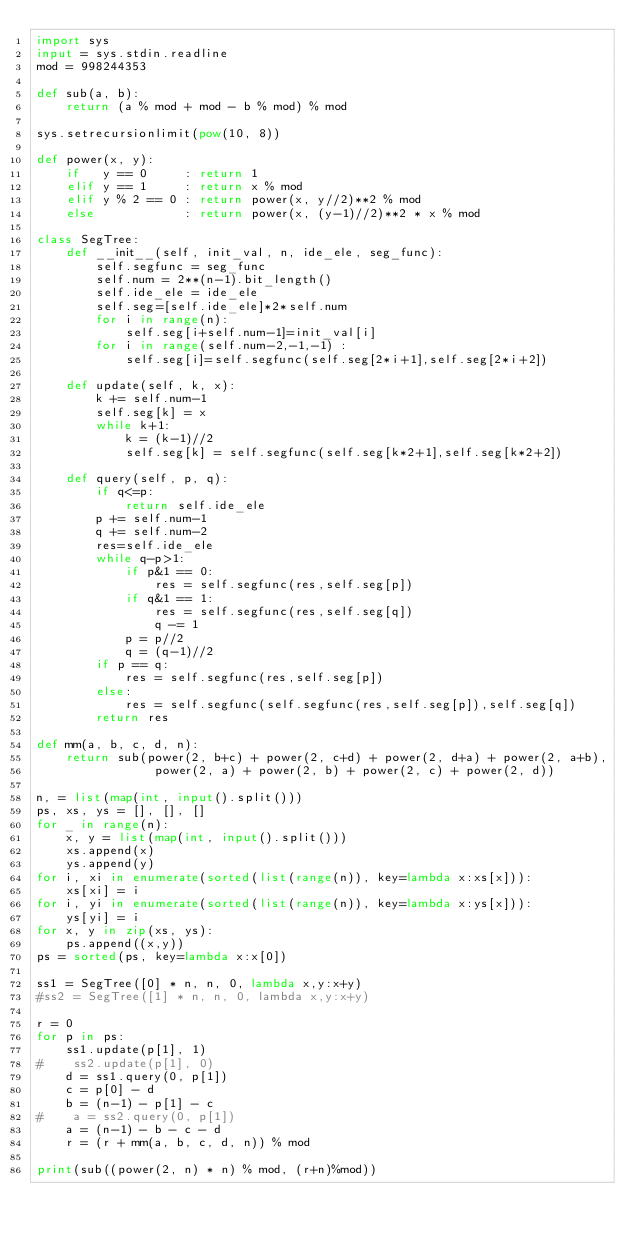Convert code to text. <code><loc_0><loc_0><loc_500><loc_500><_Python_>import sys
input = sys.stdin.readline
mod = 998244353

def sub(a, b):
    return (a % mod + mod - b % mod) % mod

sys.setrecursionlimit(pow(10, 8))

def power(x, y):
    if   y == 0     : return 1
    elif y == 1     : return x % mod
    elif y % 2 == 0 : return power(x, y//2)**2 % mod
    else            : return power(x, (y-1)//2)**2 * x % mod

class SegTree:
    def __init__(self, init_val, n, ide_ele, seg_func):
        self.segfunc = seg_func
        self.num = 2**(n-1).bit_length()
        self.ide_ele = ide_ele
        self.seg=[self.ide_ele]*2*self.num
        for i in range(n):
            self.seg[i+self.num-1]=init_val[i]    
        for i in range(self.num-2,-1,-1) :
            self.seg[i]=self.segfunc(self.seg[2*i+1],self.seg[2*i+2]) 
        
    def update(self, k, x):
        k += self.num-1
        self.seg[k] = x
        while k+1:
            k = (k-1)//2
            self.seg[k] = self.segfunc(self.seg[k*2+1],self.seg[k*2+2])
        
    def query(self, p, q):
        if q<=p:
            return self.ide_ele
        p += self.num-1
        q += self.num-2
        res=self.ide_ele
        while q-p>1:
            if p&1 == 0:
                res = self.segfunc(res,self.seg[p])
            if q&1 == 1:
                res = self.segfunc(res,self.seg[q])
                q -= 1
            p = p//2
            q = (q-1)//2
        if p == q:
            res = self.segfunc(res,self.seg[p])
        else:
            res = self.segfunc(self.segfunc(res,self.seg[p]),self.seg[q])
        return res

def mm(a, b, c, d, n):
    return sub(power(2, b+c) + power(2, c+d) + power(2, d+a) + power(2, a+b),
                power(2, a) + power(2, b) + power(2, c) + power(2, d))

n, = list(map(int, input().split()))
ps, xs, ys = [], [], []
for _ in range(n):
    x, y = list(map(int, input().split()))
    xs.append(x)
    ys.append(y)
for i, xi in enumerate(sorted(list(range(n)), key=lambda x:xs[x])):
    xs[xi] = i 
for i, yi in enumerate(sorted(list(range(n)), key=lambda x:ys[x])):
    ys[yi] = i 
for x, y in zip(xs, ys):
    ps.append((x,y))
ps = sorted(ps, key=lambda x:x[0])

ss1 = SegTree([0] * n, n, 0, lambda x,y:x+y)
#ss2 = SegTree([1] * n, n, 0, lambda x,y:x+y)

r = 0
for p in ps:
    ss1.update(p[1], 1)
#    ss2.update(p[1], 0)
    d = ss1.query(0, p[1])
    c = p[0] - d
    b = (n-1) - p[1] - c
#    a = ss2.query(0, p[1])
    a = (n-1) - b - c - d
    r = (r + mm(a, b, c, d, n)) % mod

print(sub((power(2, n) * n) % mod, (r+n)%mod))
</code> 